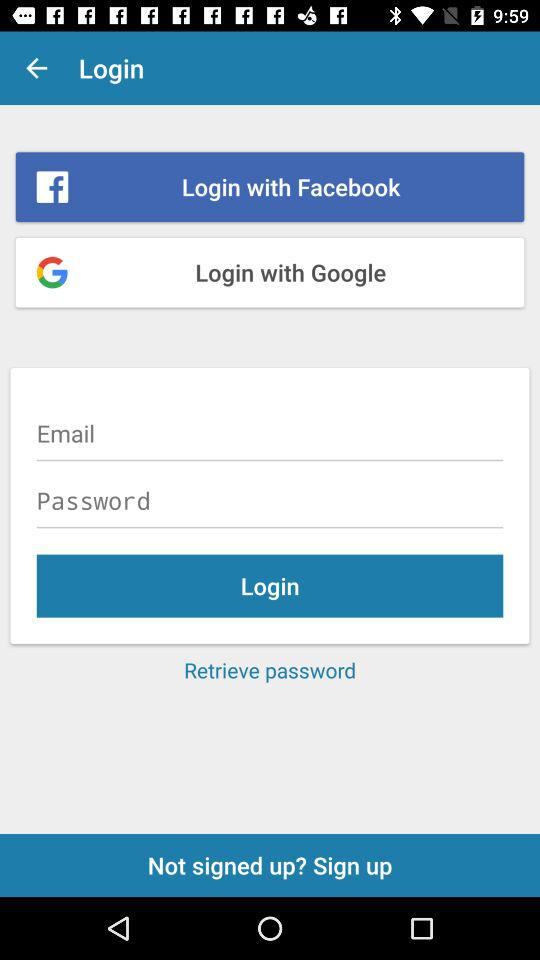What are the different applications through which we can login? You can login with "Facebook" and "Google". 